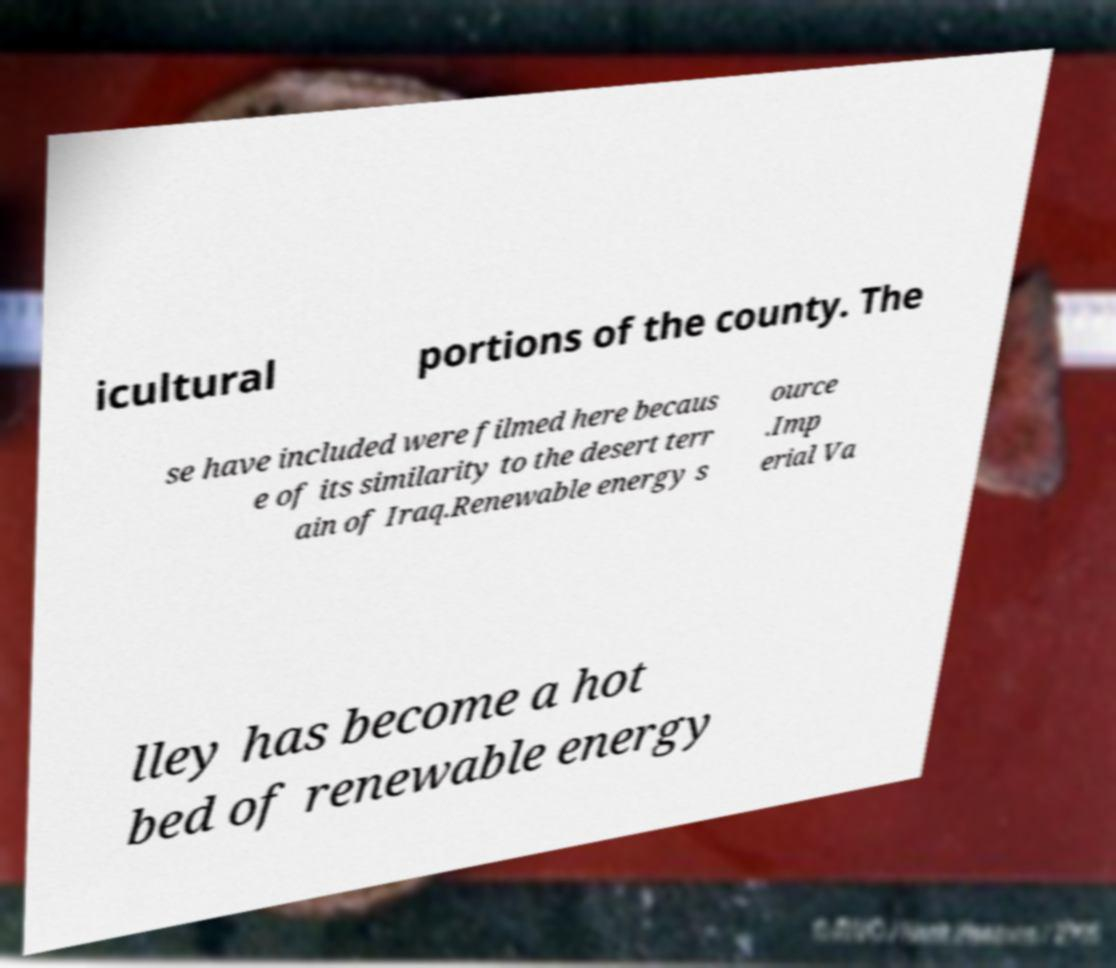Could you extract and type out the text from this image? icultural portions of the county. The se have included were filmed here becaus e of its similarity to the desert terr ain of Iraq.Renewable energy s ource .Imp erial Va lley has become a hot bed of renewable energy 